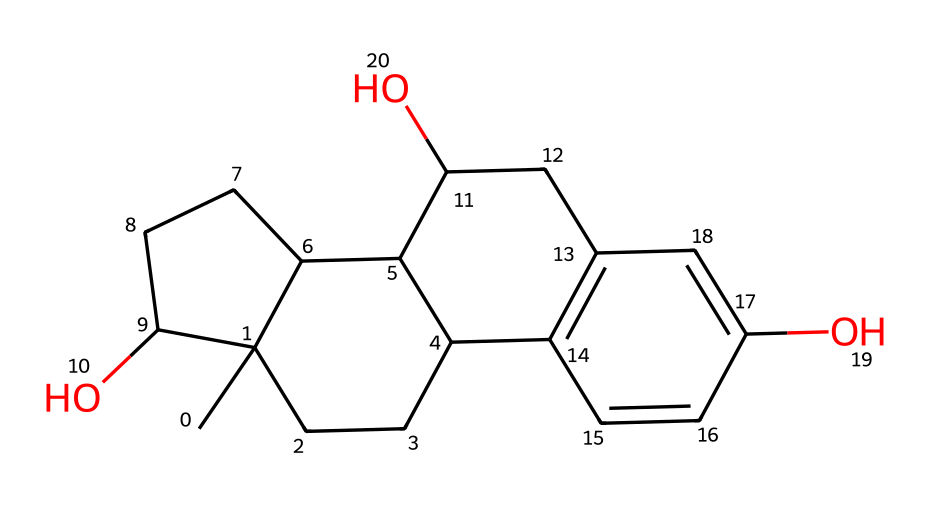What is the chemical name of the compound represented by this SMILES? The SMILES notation corresponds to a specific chemical structure. By analyzing the composition, we determine that it represents estradiol, which is a form of estrogen.
Answer: estradiol How many carbon atoms are present in this chemical? By examining the structure represented by the SMILES, we identify the number of carbon atoms in the rings and chains. There are 18 carbon atoms in total.
Answer: 18 What type of functional groups are present in this estrogen molecule? Observing the SMILES, we see hydroxyl (-OH) groups attached to the aromatic rings, indicating the presence of phenolic functional groups.
Answer: hydroxyl groups Is this compound a steroid hormone? The structure of this chemical includes multiple rings characteristic of steroids, and it is known to function as a steroid hormone (estrogen).
Answer: Yes Identify one impact of this hormone on reproductive health. Estrogen plays a crucial role in regulating menstrual cycles and is involved in the development of female reproductive tissues.
Answer: menstrual cycle regulation What is the molecular formula for this estrogen compound? From the SMILES representation, we can deduce the molecular formula by counting all the atoms: C18H24O3.
Answer: C18H24O3 What role does this hormone play in bone health? Estradiol is known to help maintain bone density by inhibiting bone resorption, thus preventing osteoporosis.
Answer: maintains bone density 